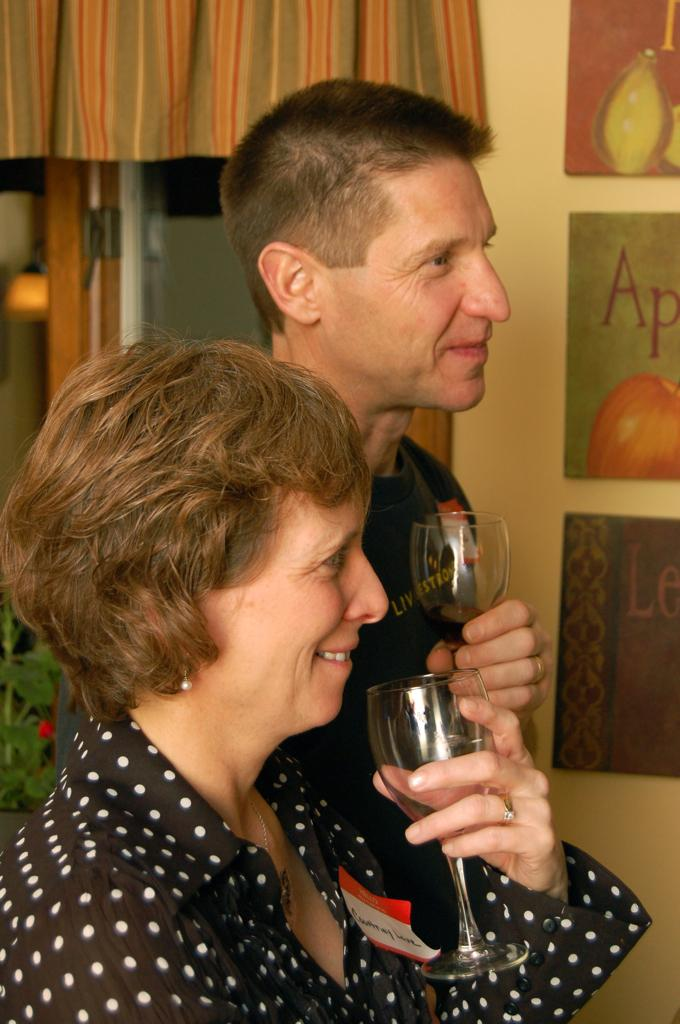How many people are present in the image? There are two people, a man and a woman, present in the image. What are the man and woman holding in their hands? Both the man and woman are holding glasses in their hands. What can be seen on the wall in the background? There are boards on the wall in the background. What architectural feature is visible in the background? There is a door in the background. What type of vegetation is present in the background? There is a plant in the background. What window treatment is visible in the background? There is a curtain in the background. What is the size of the blood droplets on the floor in the image? There are no blood droplets present in the image. 